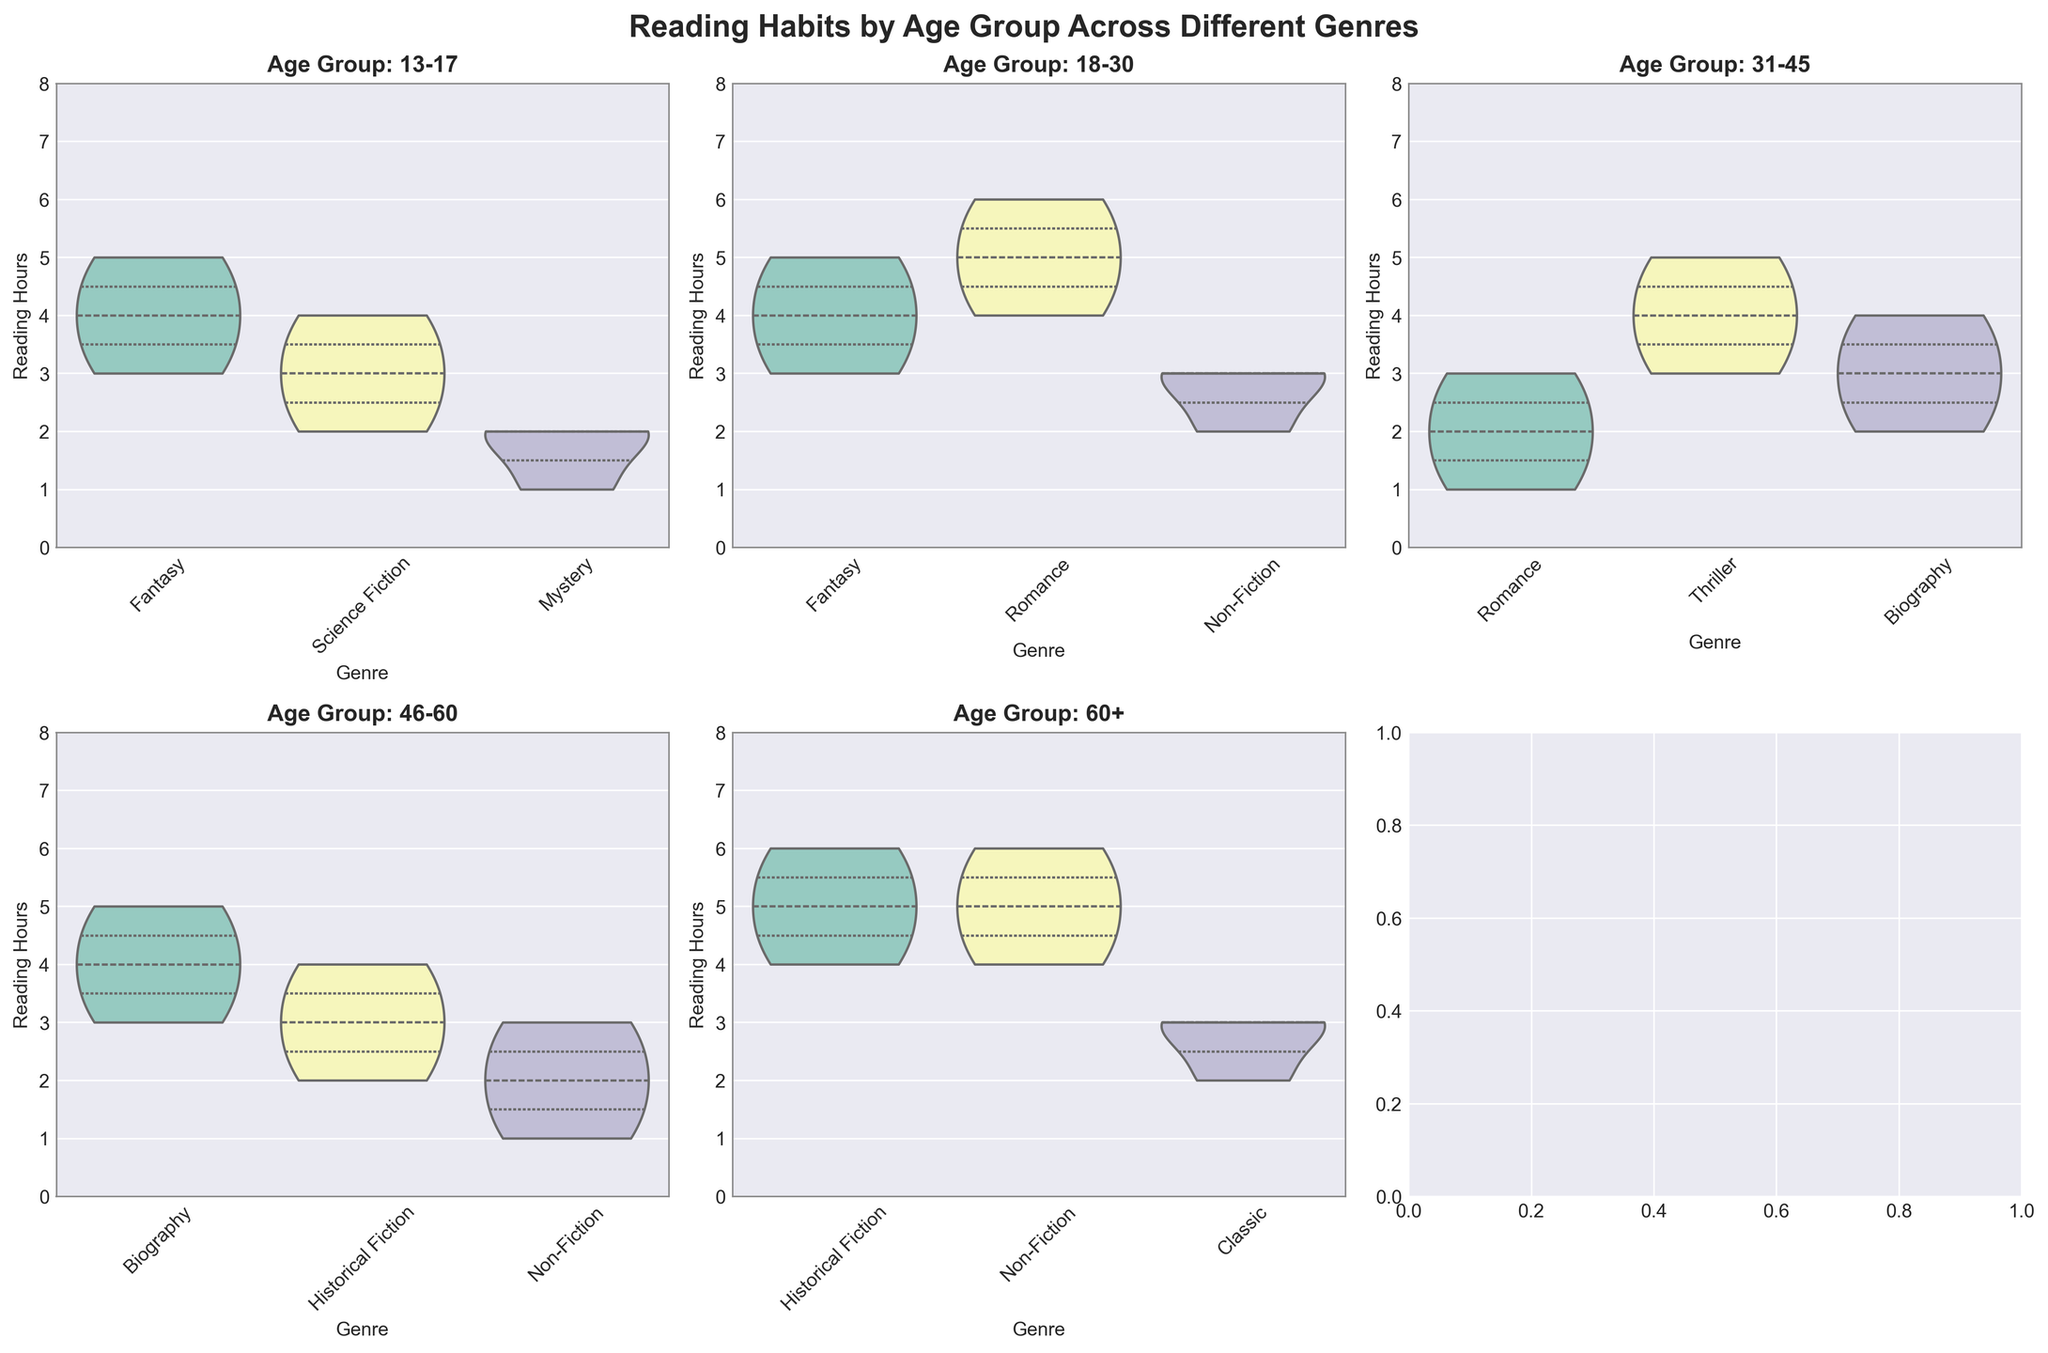What is the title of the figure? The title is prominently displayed at the top of the figure. It is "Reading Habits by Age Group Across Different Genres".
Answer: Reading Habits by Age Group Across Different Genres Which age group has the highest median reading hours for Fantasy? Looking at the subplot for each age group, for Fantasy, compare the position of the thickest part of the violin plot (median). The highest median reading hours for Fantasy is in the 13-17 and 18-30 age groups.
Answer: 13-17 and 18-30 Which genre shows the most consistent reading hours (least variability) within the 31-45 age group? The consistency (or least variability) is represented by the narrowest width of the violin plot. For the 31-45 group, Mystery displays the narrowest violin plot indicating the least variability in reading hours.
Answer: Mystery In the 60+ age group, which genre has the widest distribution range for reading hours? The widest distribution range is represented by the largest vertical span of the violin plot. For the 60+ age group, Historical Fiction shows the widest distribution.
Answer: Historical Fiction Which age group reads the least hours in Romance on average? Looking at the average position in the Romance subplot for each age group, the lowest median (and lower quartile) reading hours for Romance is seen in the 31-45 age group.
Answer: 31-45 In which genre does the 18-30 age group read the most? Find the highest median or upper end of the quartiles within the 18-30 subplot. Romance shows the highest upper quartile and median indicating the highest reading hours.
Answer: Romance Which age group shows a clear preference for a single genre based on reading hours? A clear preference is indicated by a visibly larger or more pronounced violin plot for one genre. The 13-17 age group shows a significant preference for Fantasy based on this criterion.
Answer: 13-17 How does the reading pattern for Non-Fiction compare between the 18-30 and 60+ age groups? Compare the positions and shapes of the Non-Fiction violin plots between the two age groups. The 60+ age group has higher median reading hours and wider distribution compared to the 18-30 group.
Answer: 60+ has higher median and wider distribution What is the median reading hours for Biography in the 31-45 age group? The median is the thickest part of the violin plot. For Biography in the 31-45 age group, the median reading hours are at the intersection of the thicker part of the plot, which is around 3 hours.
Answer: 3 hours Which age group and genre combination has the lowest reading hours observed? Look for the thinnest and shortest violin plots or the lowest tips of any plot in any subplot. The lowest reading hours observed are in the 46-60 age group's Non-Fiction genre, with a minimum value of 1 hour.
Answer: 46-60 Non-Fiction, 1 hour 